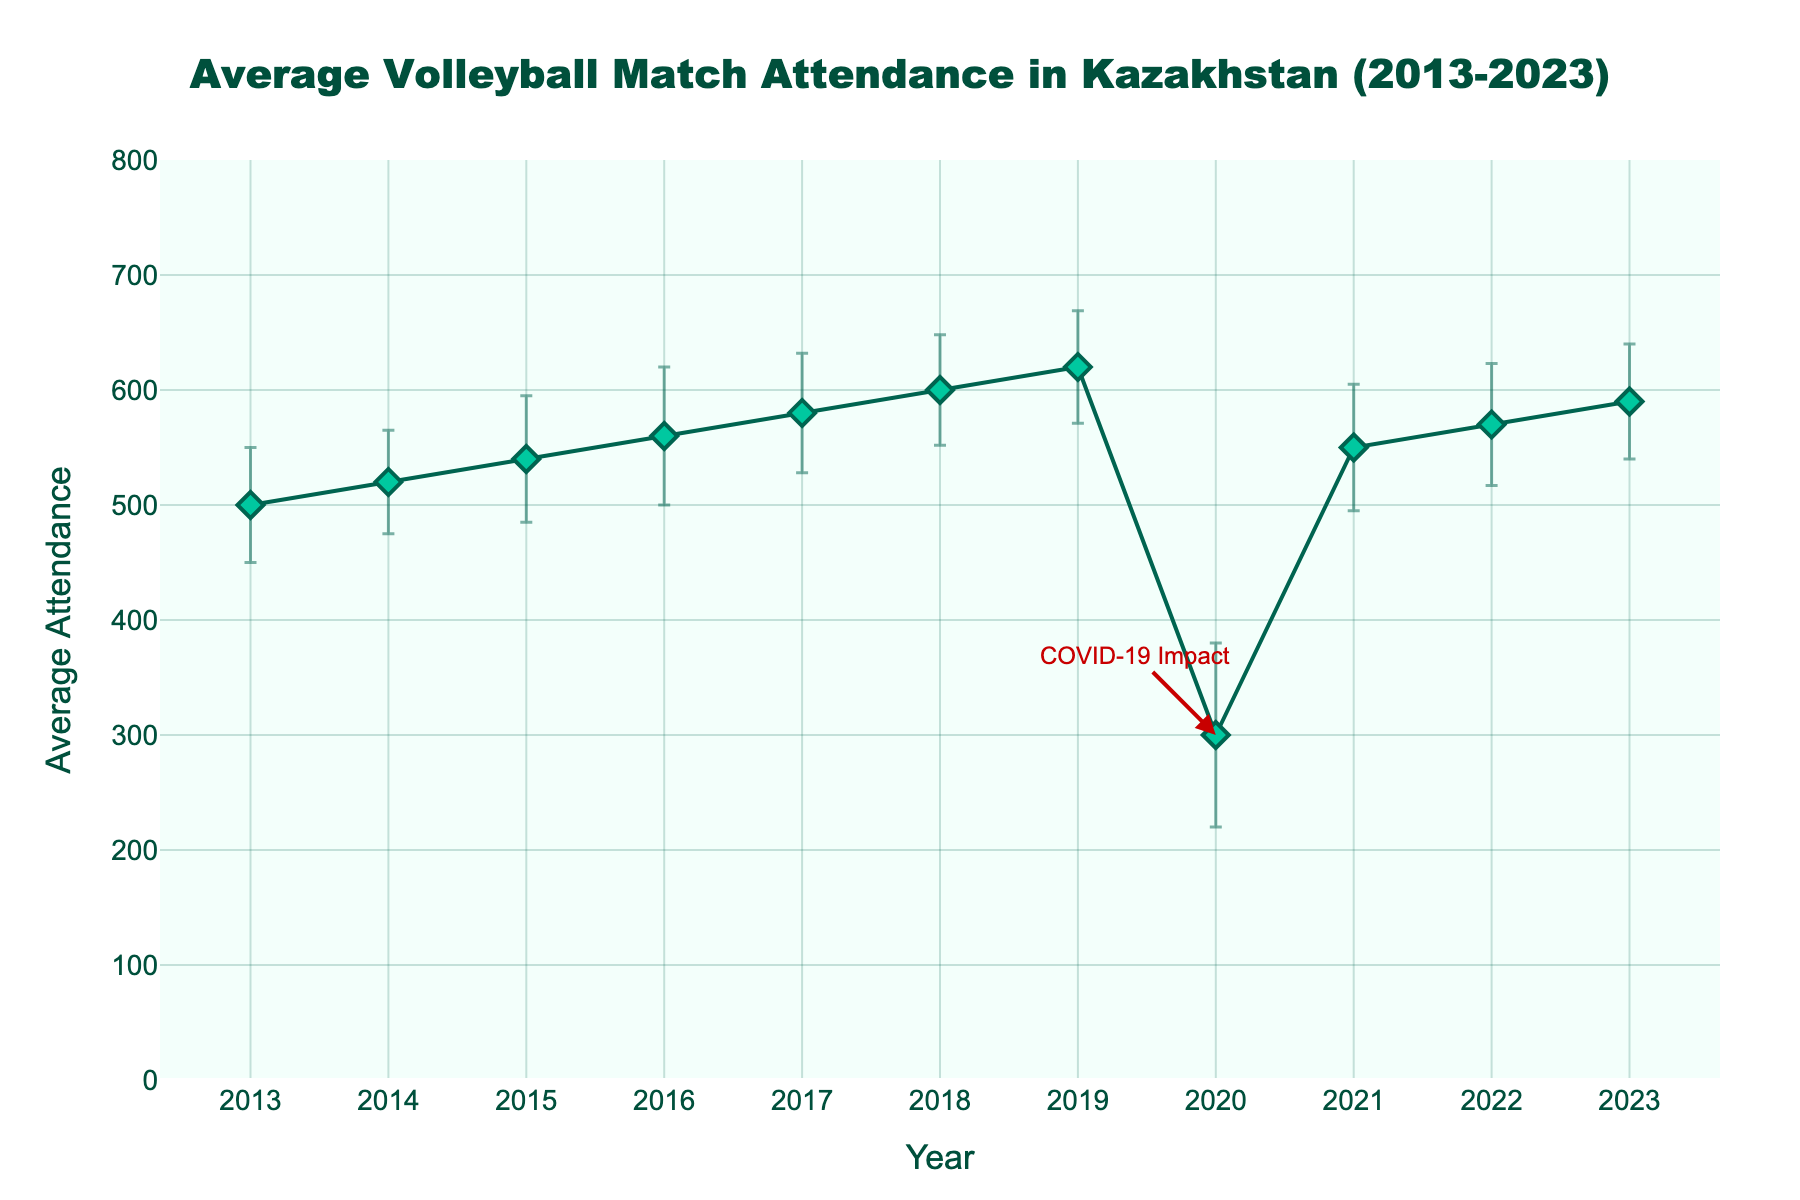What is the title of the plot? The title of the plot is located at the top center of the figure.
Answer: Average Volleyball Match Attendance in Kazakhstan (2013-2023) What is the average attendance in 2020? Locate the data point for the year 2020 on the x-axis and read the corresponding value on the y-axis.
Answer: 300 How does the average attendance in 2021 compare to 2020? Locate the data points for 2020 and 2021 on the x-axis and compare their corresponding y-values.
Answer: The average attendance in 2021 is 250 more than in 2020 What's the highest average attendance recorded over this period? Scan the plot to identify the highest data point along the y-axis and note its corresponding year.
Answer: 620 in 2019 What trend can you observe in the average attendance from 2013 to 2019? Observe the visual pattern of the data points and the overall direction of the line connecting them between 2013 and 2019.
Answer: The average attendance generally increased Which year has the highest standard deviation in attendance? Compare the lengths of the error bars for all years and identify the longest one.
Answer: 2020 What impact is noted in 2020, and how is it indicated on the plot? Look for any annotations or markings on the plot that highlight specific events or anomalies.
Answer: COVID-19 Impact, indicated by an annotation with an arrow pointing to the data point Excluding 2020, what is the average attendance in 2023 compared to 2019? Find the data points for 2019 and 2023, then compare their y-values.
Answer: The average attendance in 2023 is 30 less than in 2019 Which two consecutive years show the smallest difference in average attendance? Examine the figure to find the pair of consecutive years with the most closely spaced data points in terms of y-values.
Answer: 2017 and 2018, with a difference of 20 (580 to 600) How does the yearly variability change over the years? Observe the error bars' lengths and changes over the years to determine the trend in standard deviations.
Answer: Variability fluctuates, with notable peaks in 2015, 2016, and 2020 